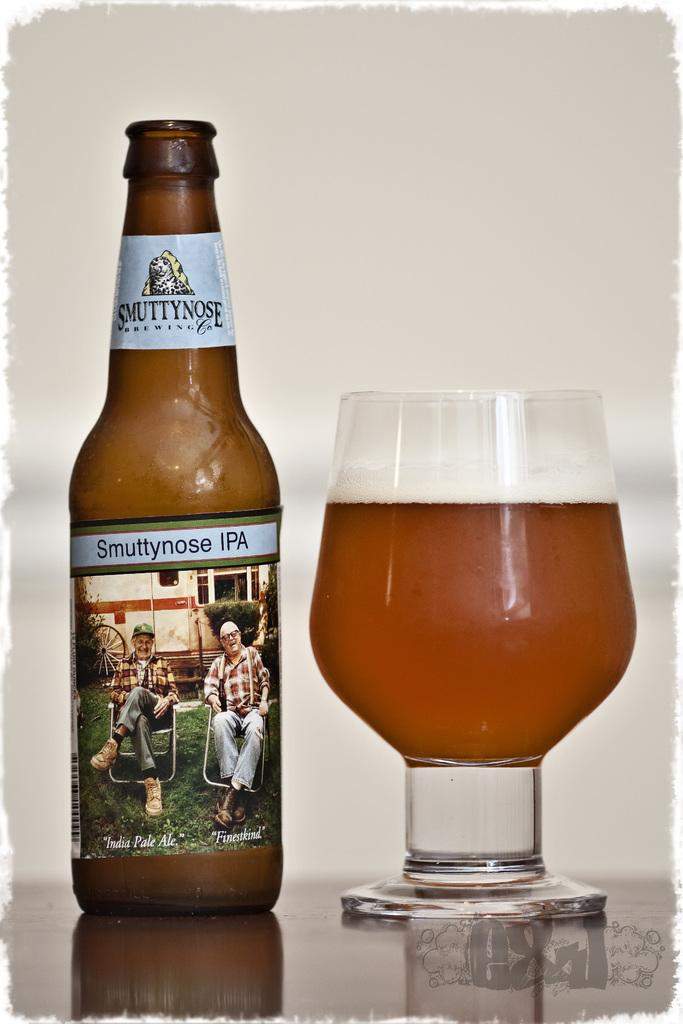<image>
Relay a brief, clear account of the picture shown. A bottle of Smuttynose IPA is next to a glass . 